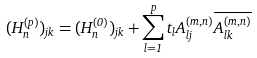Convert formula to latex. <formula><loc_0><loc_0><loc_500><loc_500>( H _ { n } ^ { ( p ) } ) _ { j k } = ( H _ { n } ^ { ( 0 ) } ) _ { j k } + \sum _ { l = 1 } ^ { p } t _ { l } A ^ { ( m , n ) } _ { l j } \overline { A ^ { ( m , n ) } _ { l k } }</formula> 